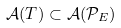<formula> <loc_0><loc_0><loc_500><loc_500>\mathcal { A } ( T ) \subset \mathcal { A } ( \mathcal { P } _ { E } )</formula> 